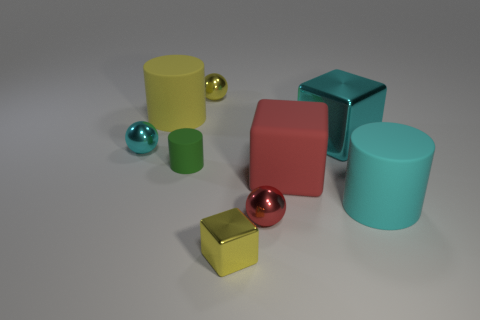Add 1 tiny green rubber objects. How many objects exist? 10 Subtract all blocks. How many objects are left? 6 Subtract 0 blue cubes. How many objects are left? 9 Subtract all big cyan objects. Subtract all large red matte balls. How many objects are left? 7 Add 9 large cyan matte cylinders. How many large cyan matte cylinders are left? 10 Add 4 tiny matte things. How many tiny matte things exist? 5 